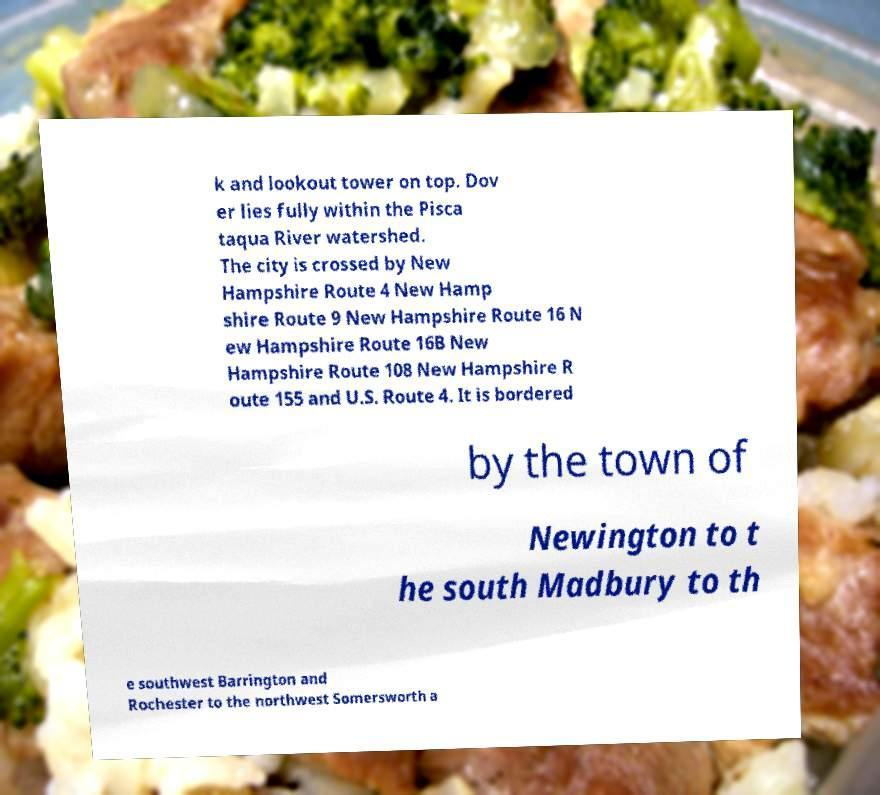I need the written content from this picture converted into text. Can you do that? k and lookout tower on top. Dov er lies fully within the Pisca taqua River watershed. The city is crossed by New Hampshire Route 4 New Hamp shire Route 9 New Hampshire Route 16 N ew Hampshire Route 16B New Hampshire Route 108 New Hampshire R oute 155 and U.S. Route 4. It is bordered by the town of Newington to t he south Madbury to th e southwest Barrington and Rochester to the northwest Somersworth a 